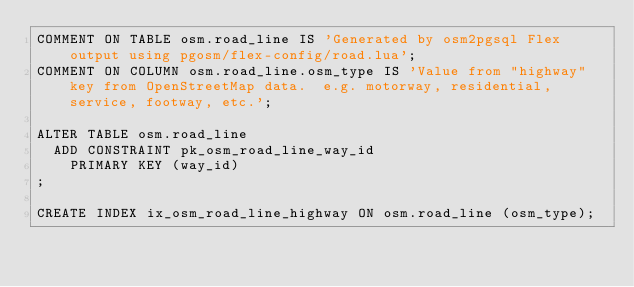<code> <loc_0><loc_0><loc_500><loc_500><_SQL_>COMMENT ON TABLE osm.road_line IS 'Generated by osm2pgsql Flex output using pgosm/flex-config/road.lua';
COMMENT ON COLUMN osm.road_line.osm_type IS 'Value from "highway" key from OpenStreetMap data.  e.g. motorway, residential, service, footway, etc.';

ALTER TABLE osm.road_line
	ADD CONSTRAINT pk_osm_road_line_way_id
    PRIMARY KEY (way_id)
;

CREATE INDEX ix_osm_road_line_highway ON osm.road_line (osm_type);
</code> 